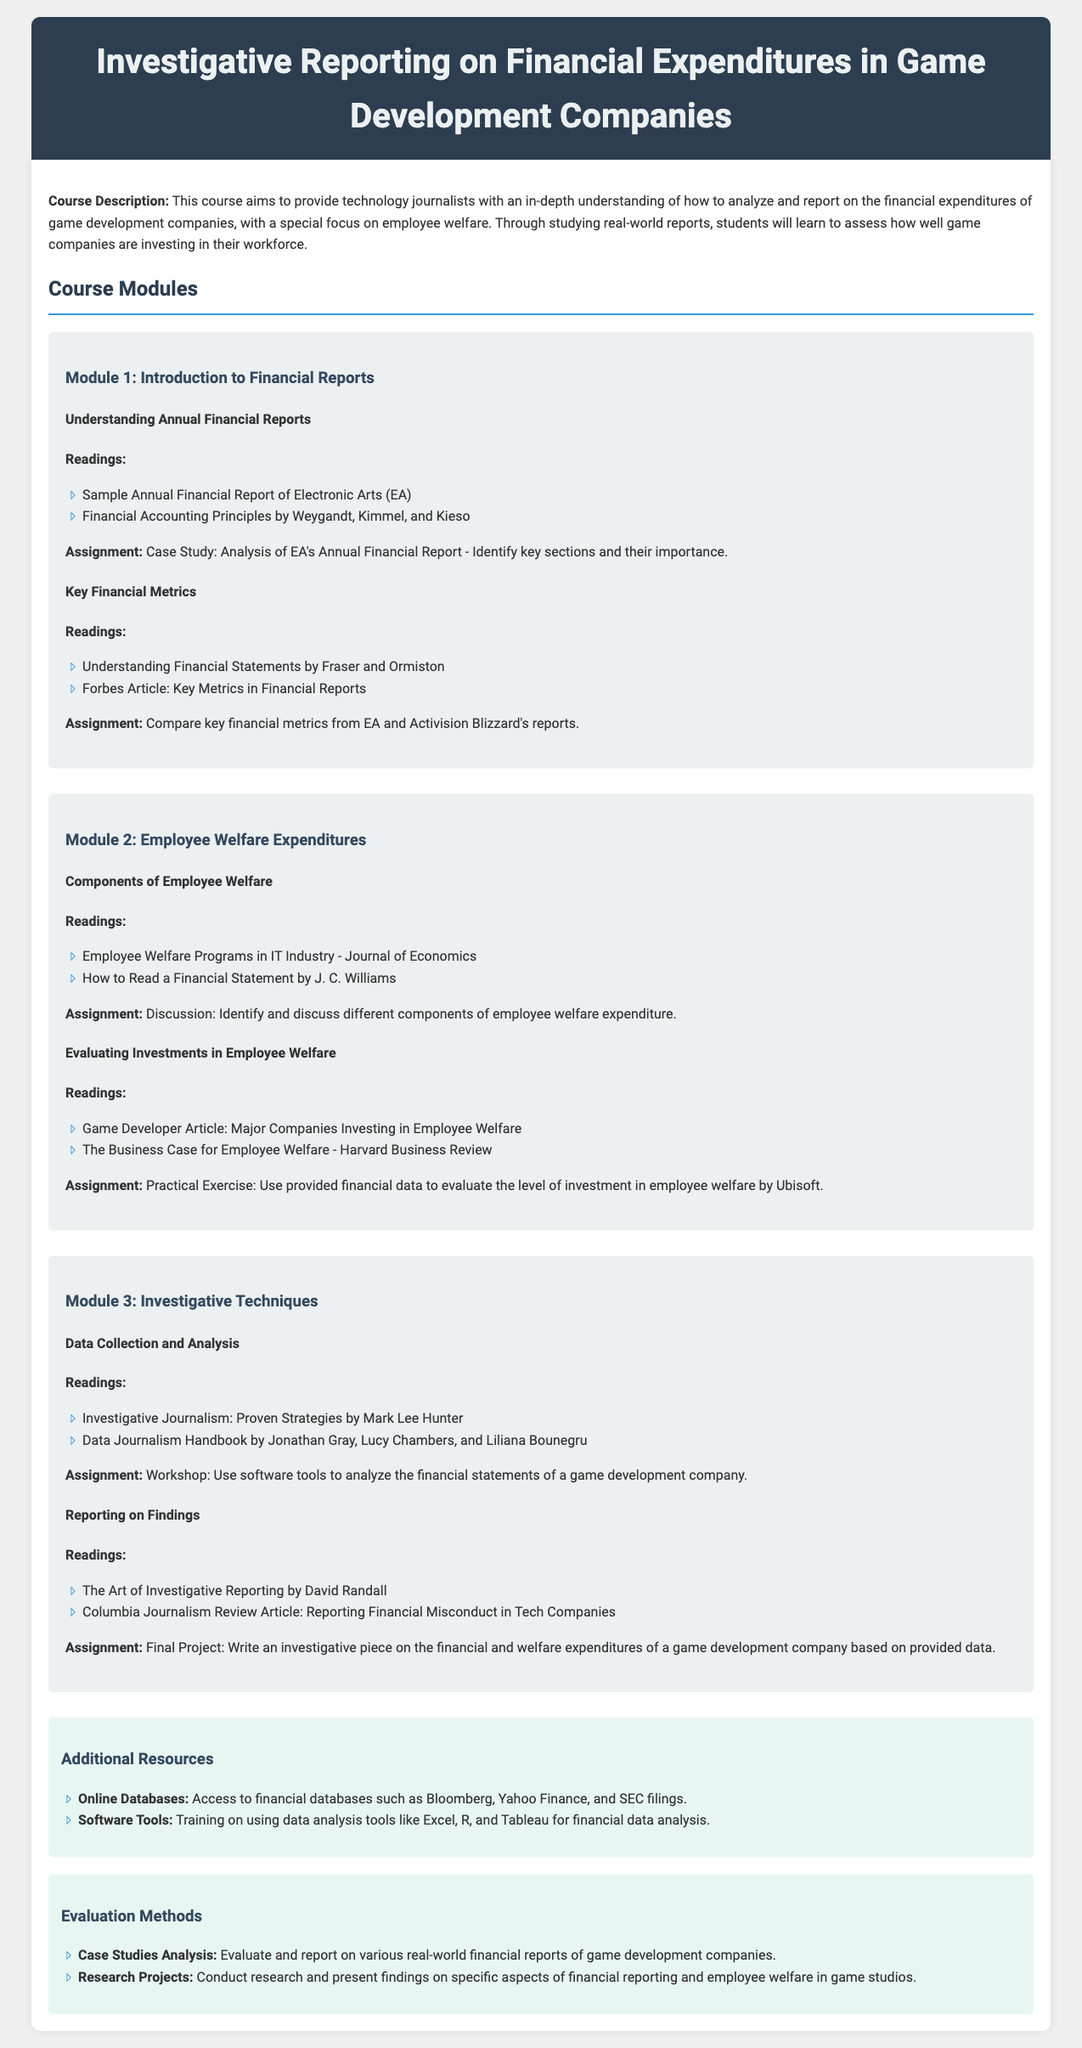What is the title of the course? The title of the course is mentioned at the top of the document and is "Investigative Reporting on Financial Expenditures in Game Development Companies."
Answer: Investigative Reporting on Financial Expenditures in Game Development Companies How many modules are in the syllabus? The document outlines three distinct modules in the course syllabus.
Answer: 3 Which company is used as a case study in Module 1? The case study in Module 1 specifically refers to the Annual Financial Report of Electronic Arts (EA).
Answer: Electronic Arts (EA) What is the focus of Module 2? Module 2 focuses specifically on Employee Welfare Expenditures and their importance in game development companies.
Answer: Employee Welfare Expenditures What type of exercise is included in Module 2 for evaluating investments? The practical exercise mentioned in Module 2 is designed to evaluate the level of investment by Ubisoft in employee welfare.
Answer: Practical Exercise What is one of the additional resources listed? One additional resource listed is access to financial databases such as Bloomberg, Yahoo Finance, and SEC filings.
Answer: Bloomberg, Yahoo Finance, and SEC filings What is the final project about? The final project involves writing an investigative piece on financial and welfare expenditures of a game development company based on provided data.
Answer: Writing an investigative piece What is the main goal of the course? The main goal of the course is to provide technology journalists with an understanding of analyzing financial expenditures, focusing on employee welfare.
Answer: Understanding of analyzing financial expenditures, focusing on employee welfare 